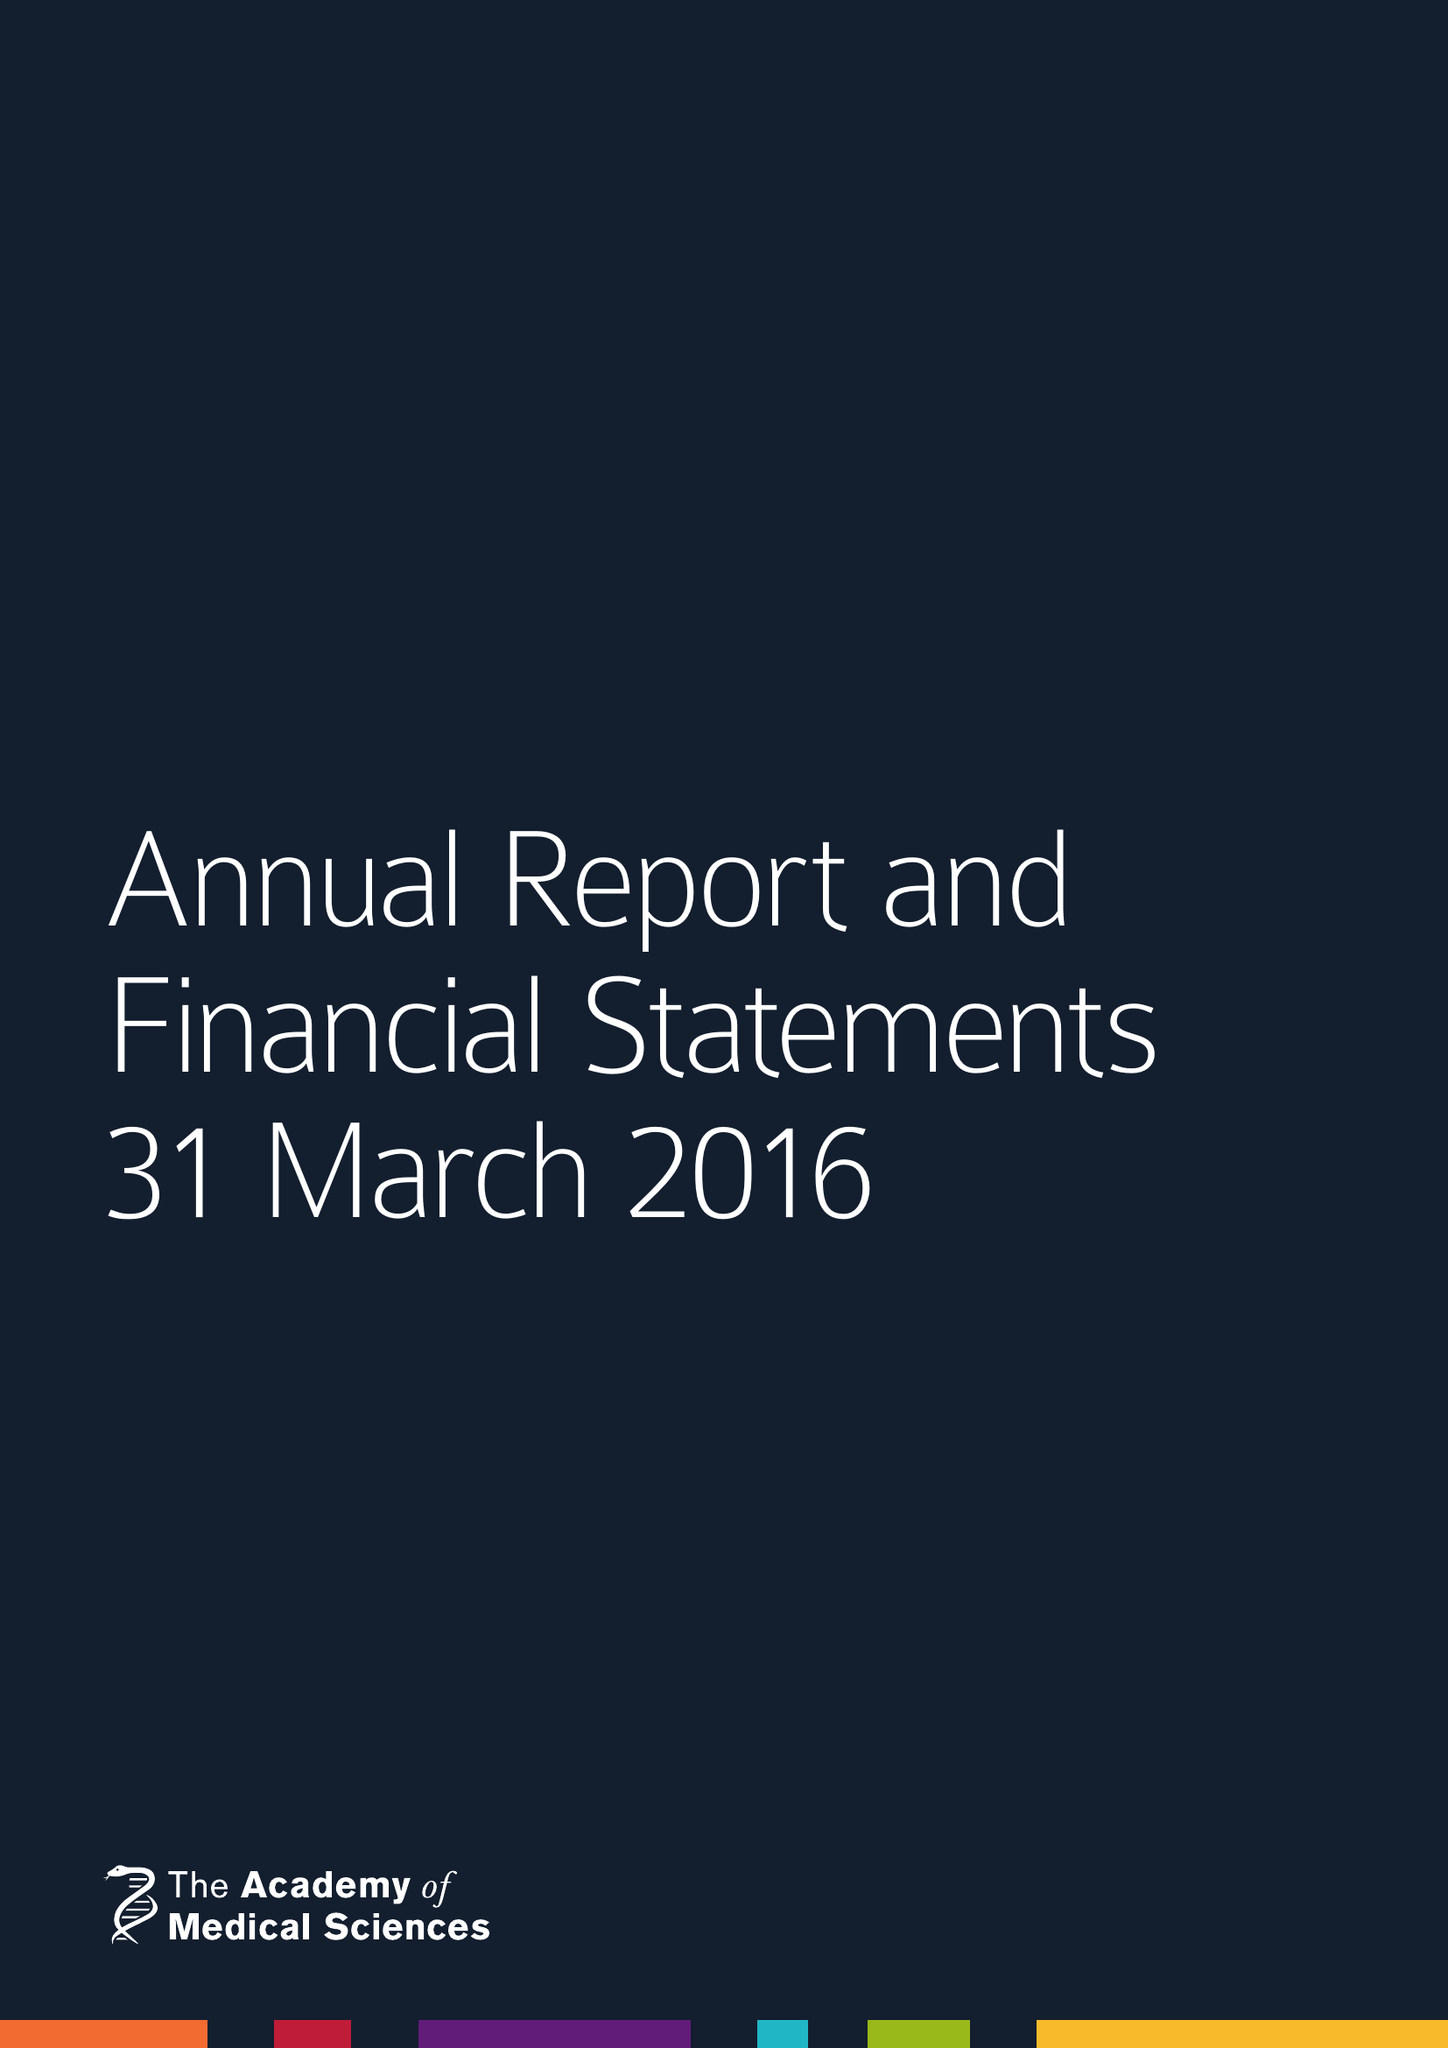What is the value for the charity_name?
Answer the question using a single word or phrase. Academy Of Medical Sciences 